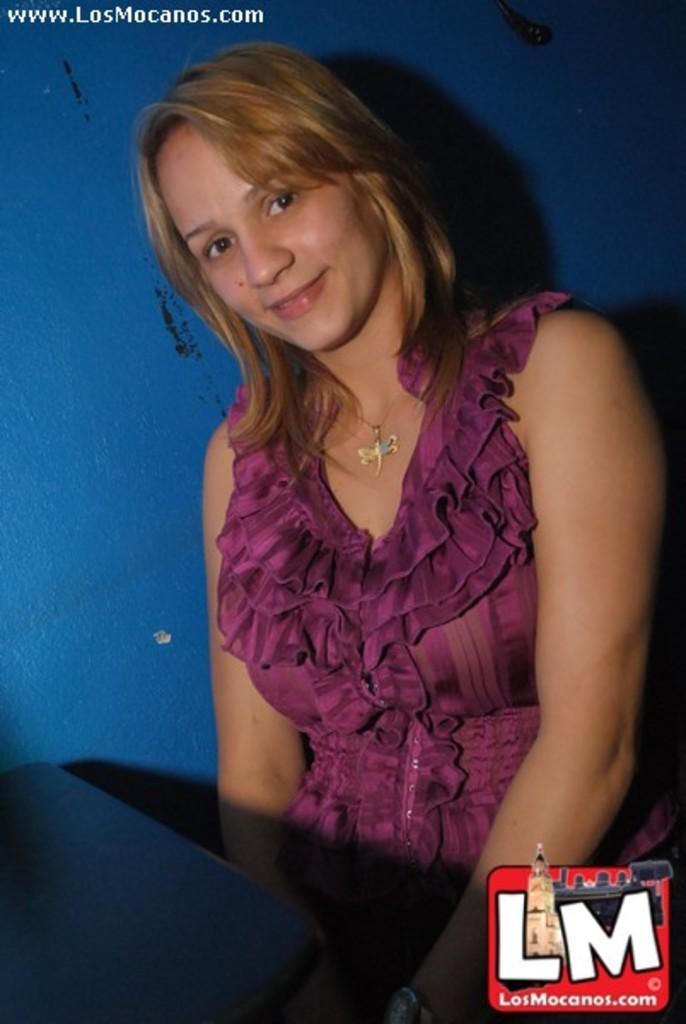In one or two sentences, can you explain what this image depicts? There is a lady in the center of the image and there is a text at the top side. 